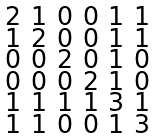Convert formula to latex. <formula><loc_0><loc_0><loc_500><loc_500>\begin{smallmatrix} 2 & 1 & 0 & 0 & 1 & 1 \\ 1 & 2 & 0 & 0 & 1 & 1 \\ 0 & 0 & 2 & 0 & 1 & 0 \\ 0 & 0 & 0 & 2 & 1 & 0 \\ 1 & 1 & 1 & 1 & 3 & 1 \\ 1 & 1 & 0 & 0 & 1 & 3 \end{smallmatrix}</formula> 